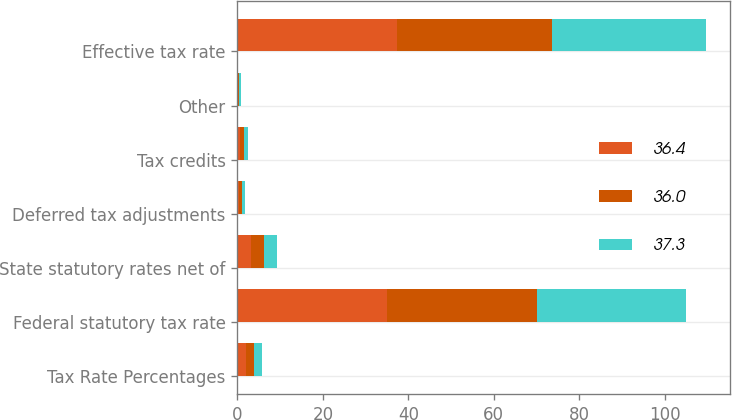<chart> <loc_0><loc_0><loc_500><loc_500><stacked_bar_chart><ecel><fcel>Tax Rate Percentages<fcel>Federal statutory tax rate<fcel>State statutory rates net of<fcel>Deferred tax adjustments<fcel>Tax credits<fcel>Other<fcel>Effective tax rate<nl><fcel>36.4<fcel>1.95<fcel>35<fcel>3.1<fcel>0.3<fcel>0.7<fcel>0.2<fcel>37.3<nl><fcel>36<fcel>1.95<fcel>35<fcel>3.2<fcel>0.8<fcel>0.8<fcel>0.2<fcel>36.4<nl><fcel>37.3<fcel>1.95<fcel>35<fcel>3<fcel>0.7<fcel>0.9<fcel>0.4<fcel>36<nl></chart> 